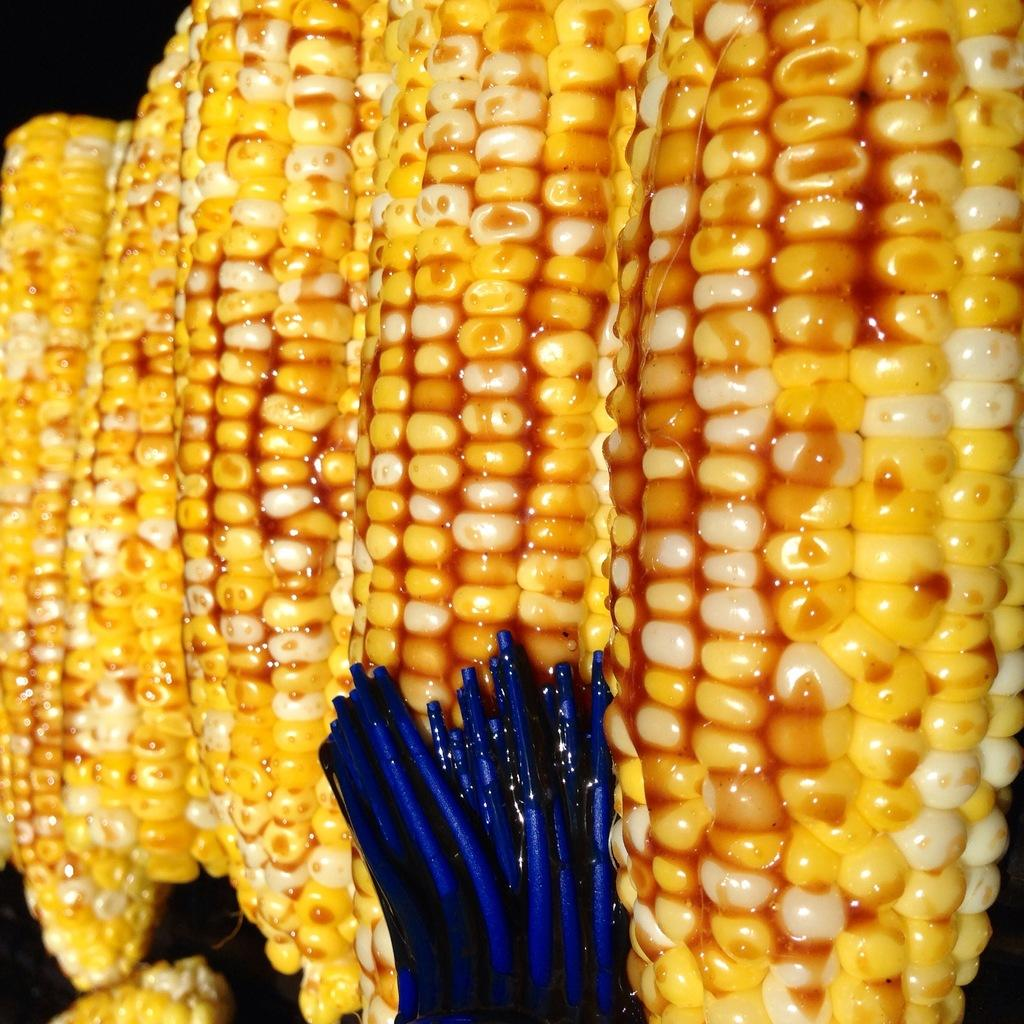What type of food is visible in the image? There is a food corn in the image. What object is present in the image that is not related to the food corn? There is a brush in blue color in the image. What might the blue brush be used for in relation to the food corn? The brush is likely used to apply something on top of the food corn. Can you see any worms crawling on the food corn in the image? There are no worms visible on the food corn in the image. 